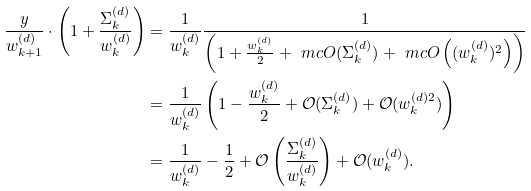<formula> <loc_0><loc_0><loc_500><loc_500>\frac { y } { w _ { k + 1 } ^ { ( d ) } } \cdot \left ( 1 + \frac { \Sigma _ { k } ^ { ( d ) } } { w _ { k } ^ { ( d ) } } \right ) & = \frac { 1 } { w _ { k } ^ { ( d ) } } \frac { 1 } { \left ( 1 + \frac { w _ { k } ^ { ( d ) } } { 2 } + \ m c { O } ( \Sigma _ { k } ^ { ( d ) } ) + \ m c { O } \left ( ( w _ { k } ^ { ( d ) } ) ^ { 2 } \right ) \right ) } \\ & = \frac { 1 } { w _ { k } ^ { ( d ) } } \left ( 1 - \frac { w _ { k } ^ { ( d ) } } { 2 } + \mathcal { O } ( \Sigma _ { k } ^ { ( d ) } ) + \mathcal { O } ( w _ { k } ^ { ( d ) 2 } ) \right ) \\ & = \frac { 1 } { w _ { k } ^ { ( d ) } } - \frac { 1 } { 2 } + \mathcal { O } \left ( \frac { \Sigma _ { k } ^ { ( d ) } } { w _ { k } ^ { ( d ) } } \right ) + \mathcal { O } ( w _ { k } ^ { ( d ) } ) .</formula> 